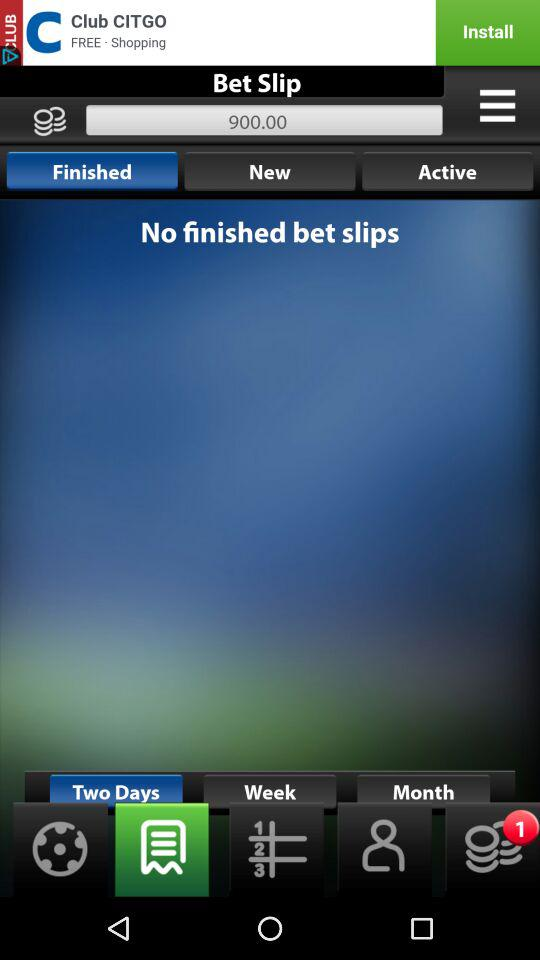How many bet slips are finished? There are no finished bet slips. 